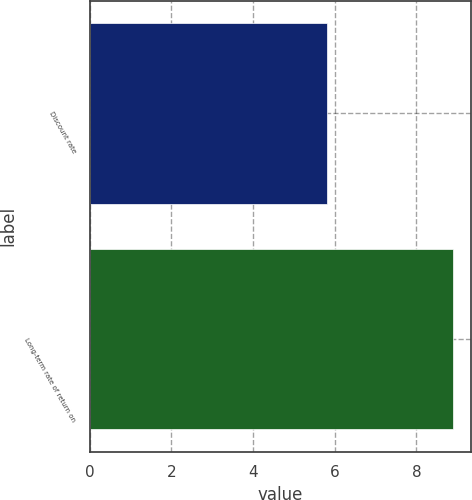<chart> <loc_0><loc_0><loc_500><loc_500><bar_chart><fcel>Discount rate<fcel>Long-term rate of return on<nl><fcel>5.8<fcel>8.9<nl></chart> 